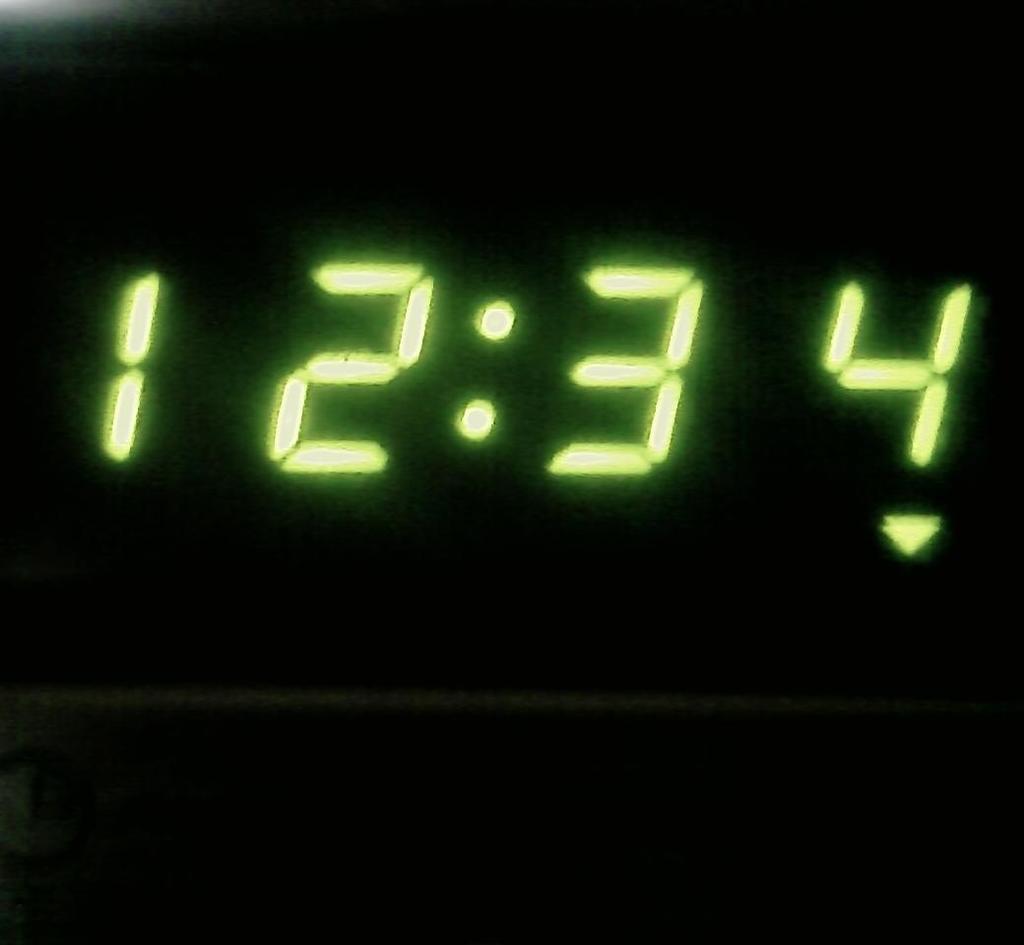What is the last number?
Your response must be concise. 4. 